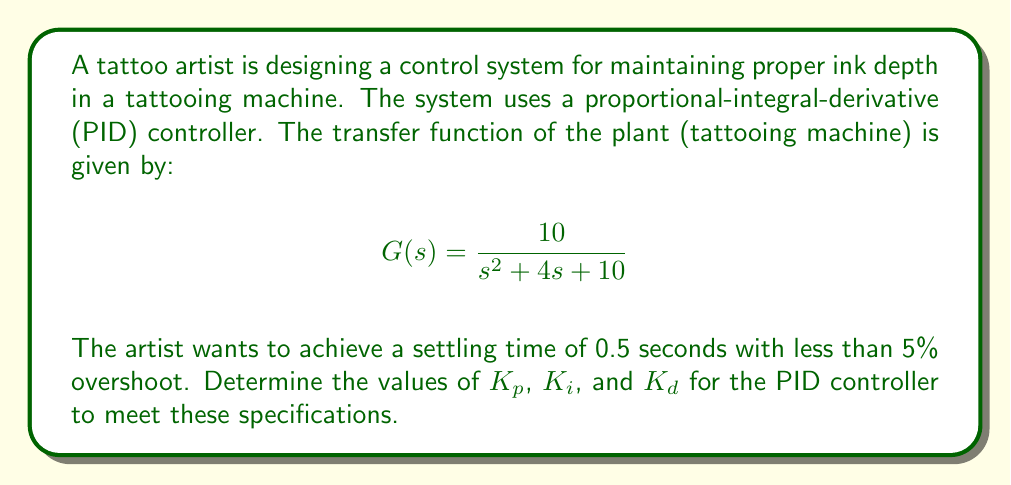Could you help me with this problem? To solve this problem, we'll follow these steps:

1) For a second-order system, the general form of the closed-loop transfer function with a PID controller is:

   $$T(s) = \frac{K_d s^2 + K_p s + K_i}{s^3 + (4+K_d)s^2 + (10+K_p)s + K_i}$$

2) We can compare this to the standard form of a second-order system:

   $$T(s) = \frac{\omega_n^2}{s^2 + 2\zeta\omega_n s + \omega_n^2}$$

3) For less than 5% overshoot, we need a damping ratio $\zeta \approx 0.69$.

4) The settling time $t_s$ is related to $\omega_n$ by:

   $$t_s \approx \frac{4}{\zeta\omega_n}$$

   Solving for $\omega_n$:

   $$\omega_n = \frac{4}{\zeta t_s} = \frac{4}{0.69 \cdot 0.5} \approx 11.59$$

5) Now we can equate our closed-loop transfer function to the standard form:

   $$\frac{K_d s^2 + K_p s + K_i}{s^3 + (4+K_d)s^2 + (10+K_p)s + K_i} = \frac{11.59^2}{s^2 + 2(0.69)(11.59)s + 11.59^2}$$

6) Comparing coefficients:

   $K_d = 11.59^2 / 10 = 13.43$
   $4 + K_d = 2(0.69)(11.59)$, so $K_p = 2(0.69)(11.59) - 4 - 13.43 = -1.43$
   $K_i = 11.59^2 = 134.33$

7) Therefore, the PID controller parameters are:
   $K_p = -1.43$, $K_i = 134.33$, and $K_d = 13.43$
Answer: $K_p = -1.43$, $K_i = 134.33$, $K_d = 13.43$ 